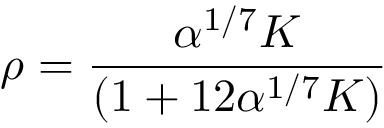<formula> <loc_0><loc_0><loc_500><loc_500>\rho = \frac { \alpha ^ { 1 / 7 } K } { ( 1 + 1 2 \alpha ^ { 1 / 7 } K ) }</formula> 